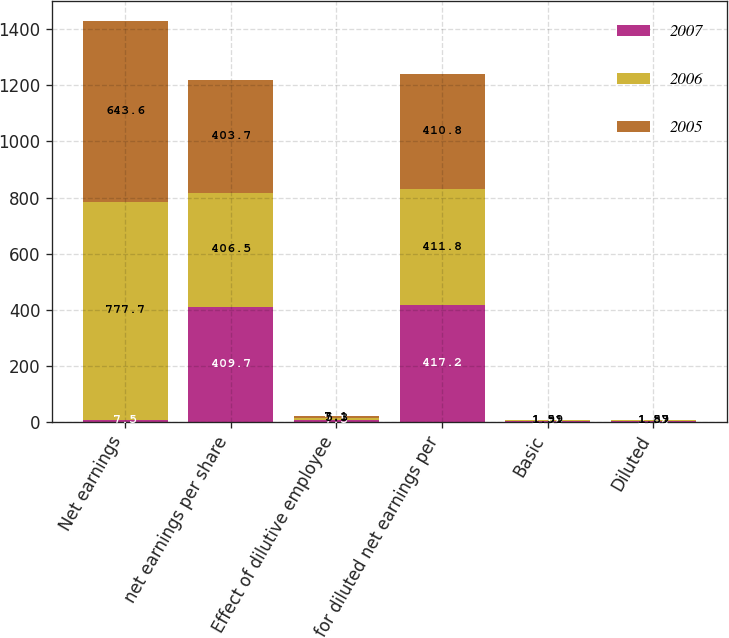Convert chart to OTSL. <chart><loc_0><loc_0><loc_500><loc_500><stacked_bar_chart><ecel><fcel>Net earnings<fcel>net earnings per share<fcel>Effect of dilutive employee<fcel>for diluted net earnings per<fcel>Basic<fcel>Diluted<nl><fcel>2007<fcel>7.5<fcel>409.7<fcel>7.5<fcel>417.2<fcel>2.48<fcel>2.44<nl><fcel>2006<fcel>777.7<fcel>406.5<fcel>5.3<fcel>411.8<fcel>1.91<fcel>1.89<nl><fcel>2005<fcel>643.6<fcel>403.7<fcel>7.1<fcel>410.8<fcel>1.59<fcel>1.57<nl></chart> 